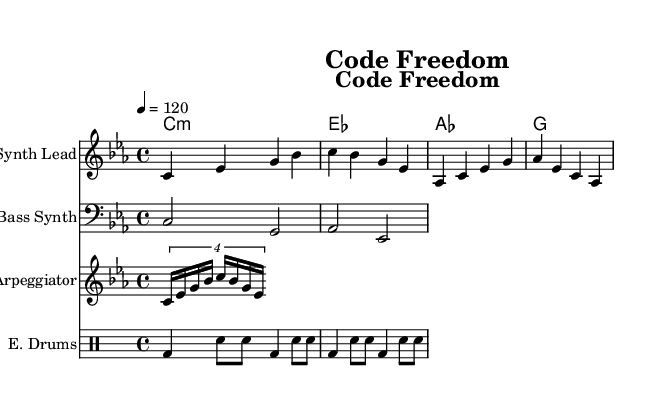What is the key signature of this music? The key signature indicated at the beginning of the score is C minor, which includes three flats (B flat, E flat, and A flat).
Answer: C minor What is the time signature of this piece? The time signature shown at the beginning of the score is 4/4, which means there are four beats in each measure and the quarter note gets one beat.
Answer: 4/4 What is the tempo marking for this piece? The tempo is marked as quarter note equals 120, indicating a moderate pace with 120 beats per minute.
Answer: 120 How many different instruments are featured in this score? There are four distinct staves for different instruments: a Synth Lead, a Bass Synth, an Arpeggiator, and Electronic Drums, making a total of four instruments.
Answer: 4 What chord follows A flat in the chord progression? In the chord progression sequence, A flat is followed by E flat, which is the next chord in the cycle.
Answer: E flat What type of musical texture is predominantly used in this piece? The piece primarily utilizes a polyphonic texture, where several independent lines (the melody, bass line, and arpeggiator) are played simultaneously, characteristic of electronic music structures, enhancing the complexity.
Answer: Polyphonic How many measures does the melody consist of? The melody consists of 8 measures, each containing a distinct combination of notes, as represented in the score.
Answer: 8 